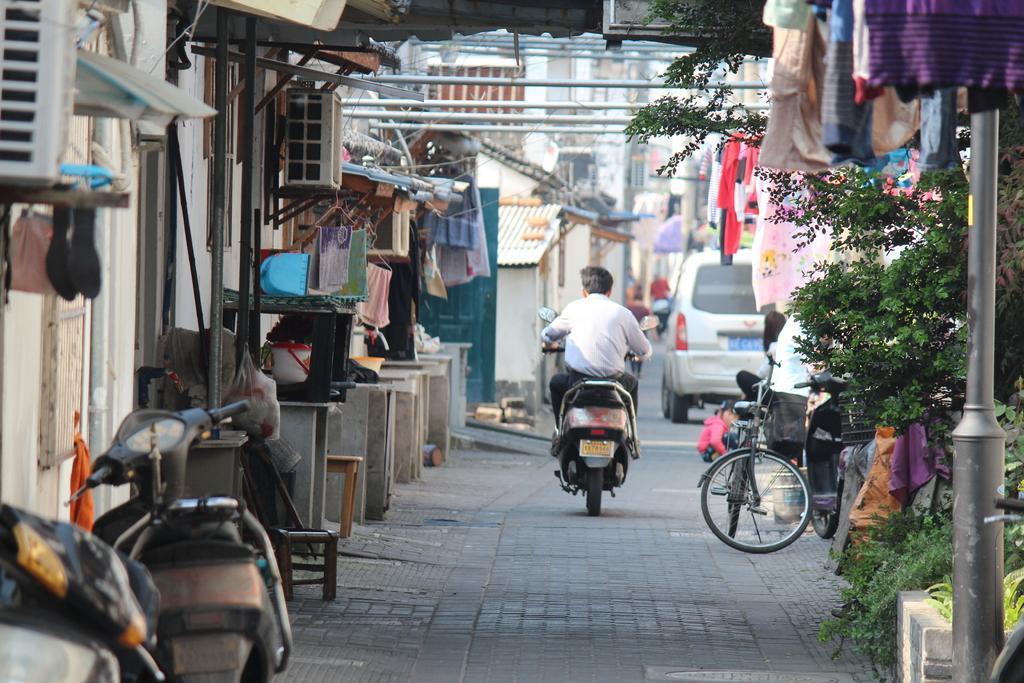Can you describe this image briefly? A man is riding bike, here there are other vehicles, here there is a tree, these are clothes, here there are houses. 